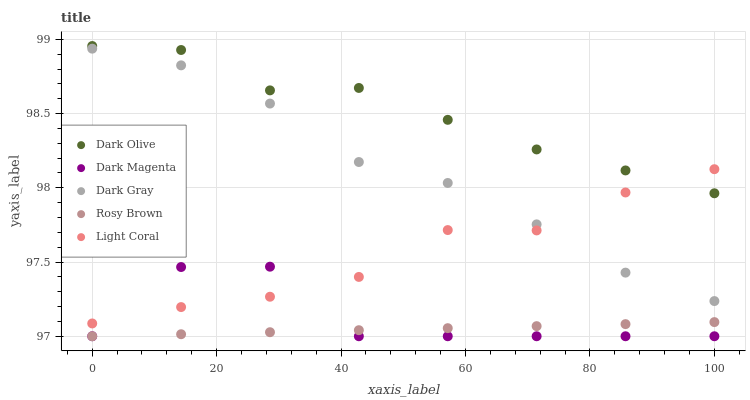Does Rosy Brown have the minimum area under the curve?
Answer yes or no. Yes. Does Dark Olive have the maximum area under the curve?
Answer yes or no. Yes. Does Light Coral have the minimum area under the curve?
Answer yes or no. No. Does Light Coral have the maximum area under the curve?
Answer yes or no. No. Is Rosy Brown the smoothest?
Answer yes or no. Yes. Is Dark Magenta the roughest?
Answer yes or no. Yes. Is Light Coral the smoothest?
Answer yes or no. No. Is Light Coral the roughest?
Answer yes or no. No. Does Rosy Brown have the lowest value?
Answer yes or no. Yes. Does Light Coral have the lowest value?
Answer yes or no. No. Does Dark Olive have the highest value?
Answer yes or no. Yes. Does Light Coral have the highest value?
Answer yes or no. No. Is Dark Magenta less than Dark Gray?
Answer yes or no. Yes. Is Dark Gray greater than Dark Magenta?
Answer yes or no. Yes. Does Light Coral intersect Dark Magenta?
Answer yes or no. Yes. Is Light Coral less than Dark Magenta?
Answer yes or no. No. Is Light Coral greater than Dark Magenta?
Answer yes or no. No. Does Dark Magenta intersect Dark Gray?
Answer yes or no. No. 